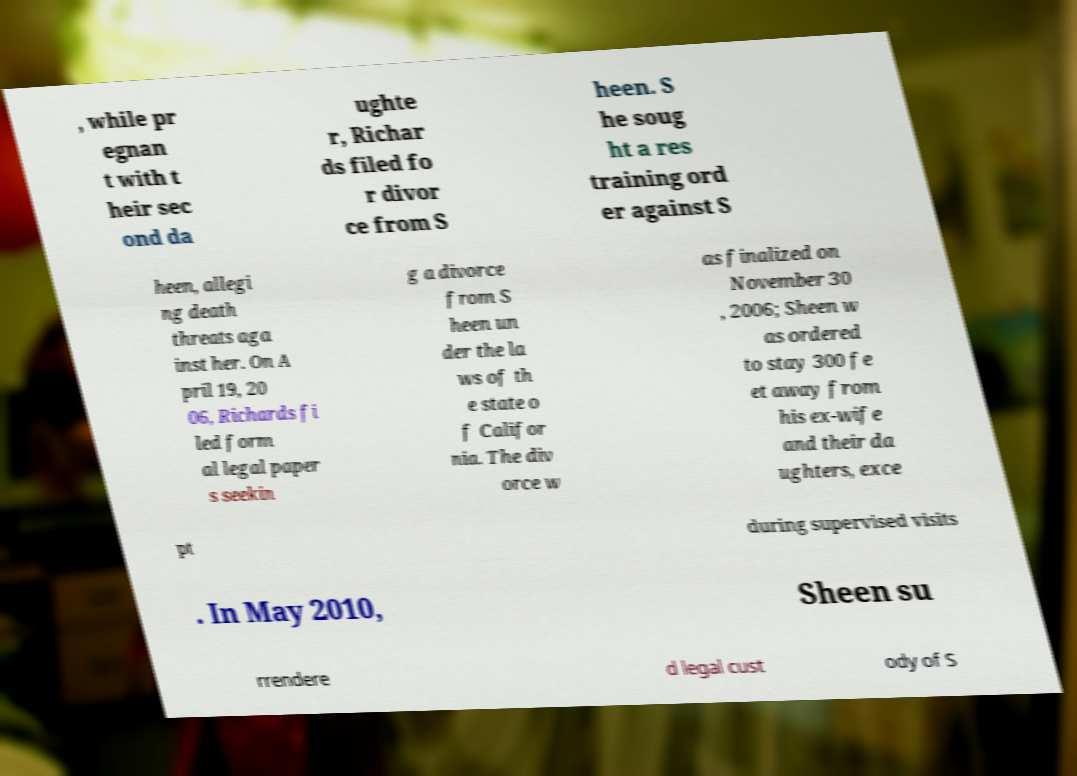What messages or text are displayed in this image? I need them in a readable, typed format. , while pr egnan t with t heir sec ond da ughte r, Richar ds filed fo r divor ce from S heen. S he soug ht a res training ord er against S heen, allegi ng death threats aga inst her. On A pril 19, 20 06, Richards fi led form al legal paper s seekin g a divorce from S heen un der the la ws of th e state o f Califor nia. The div orce w as finalized on November 30 , 2006; Sheen w as ordered to stay 300 fe et away from his ex-wife and their da ughters, exce pt during supervised visits . In May 2010, Sheen su rrendere d legal cust ody of S 